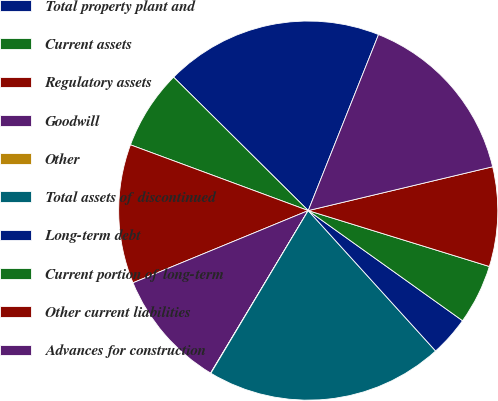Convert chart. <chart><loc_0><loc_0><loc_500><loc_500><pie_chart><fcel>Total property plant and<fcel>Current assets<fcel>Regulatory assets<fcel>Goodwill<fcel>Other<fcel>Total assets of discontinued<fcel>Long-term debt<fcel>Current portion of long-term<fcel>Other current liabilities<fcel>Advances for construction<nl><fcel>18.62%<fcel>6.79%<fcel>11.86%<fcel>10.17%<fcel>0.03%<fcel>20.31%<fcel>3.41%<fcel>5.1%<fcel>8.48%<fcel>15.24%<nl></chart> 